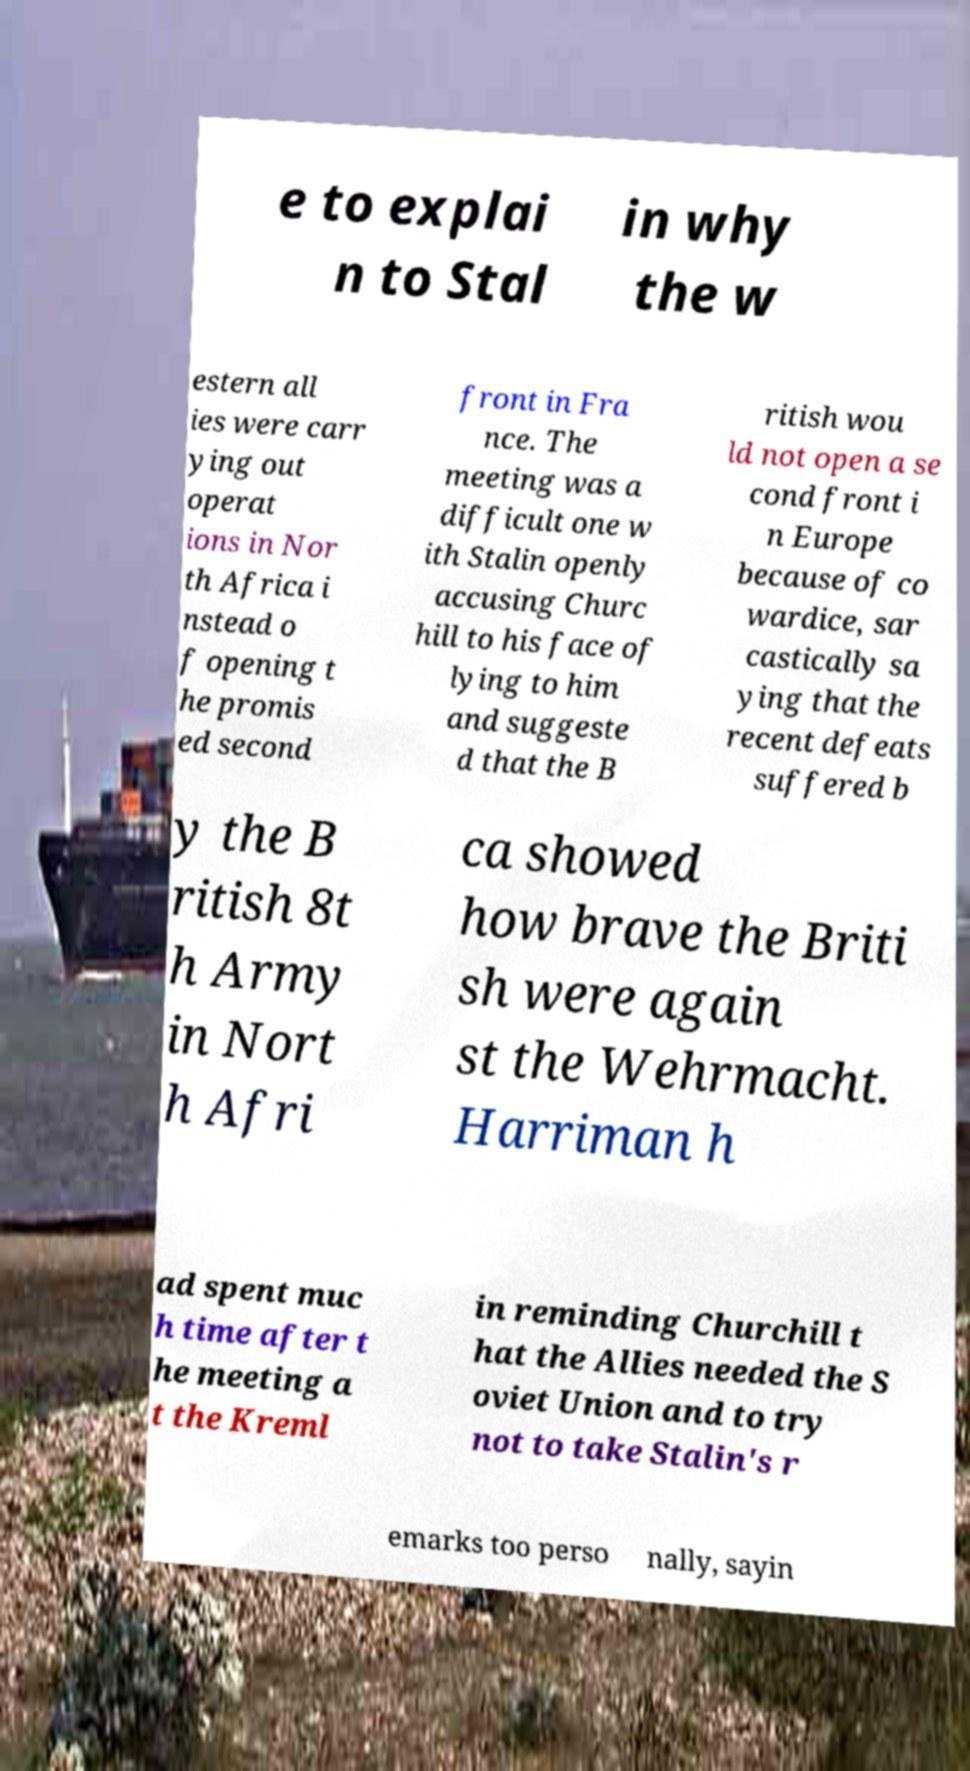What messages or text are displayed in this image? I need them in a readable, typed format. e to explai n to Stal in why the w estern all ies were carr ying out operat ions in Nor th Africa i nstead o f opening t he promis ed second front in Fra nce. The meeting was a difficult one w ith Stalin openly accusing Churc hill to his face of lying to him and suggeste d that the B ritish wou ld not open a se cond front i n Europe because of co wardice, sar castically sa ying that the recent defeats suffered b y the B ritish 8t h Army in Nort h Afri ca showed how brave the Briti sh were again st the Wehrmacht. Harriman h ad spent muc h time after t he meeting a t the Kreml in reminding Churchill t hat the Allies needed the S oviet Union and to try not to take Stalin's r emarks too perso nally, sayin 